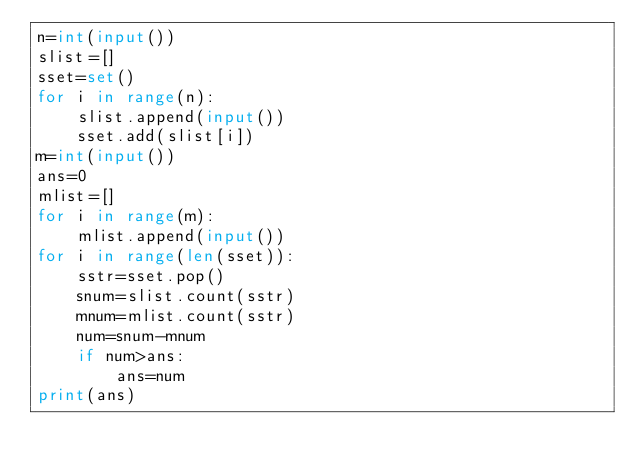<code> <loc_0><loc_0><loc_500><loc_500><_Python_>n=int(input())
slist=[]
sset=set()
for i in range(n):
    slist.append(input())
    sset.add(slist[i])
m=int(input())
ans=0
mlist=[]
for i in range(m):
    mlist.append(input())
for i in range(len(sset)):
    sstr=sset.pop()
    snum=slist.count(sstr)
    mnum=mlist.count(sstr)
    num=snum-mnum
    if num>ans:
        ans=num
print(ans)
</code> 